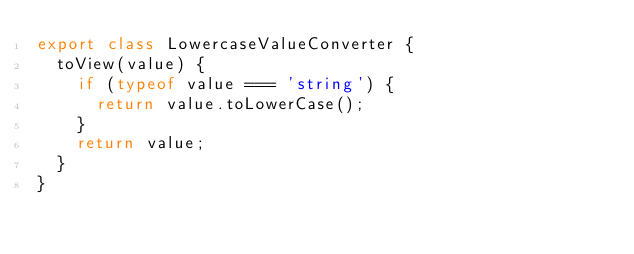Convert code to text. <code><loc_0><loc_0><loc_500><loc_500><_JavaScript_>export class LowercaseValueConverter {
  toView(value) {
    if (typeof value === 'string') {
      return value.toLowerCase();
    }
    return value;
  }
}
</code> 